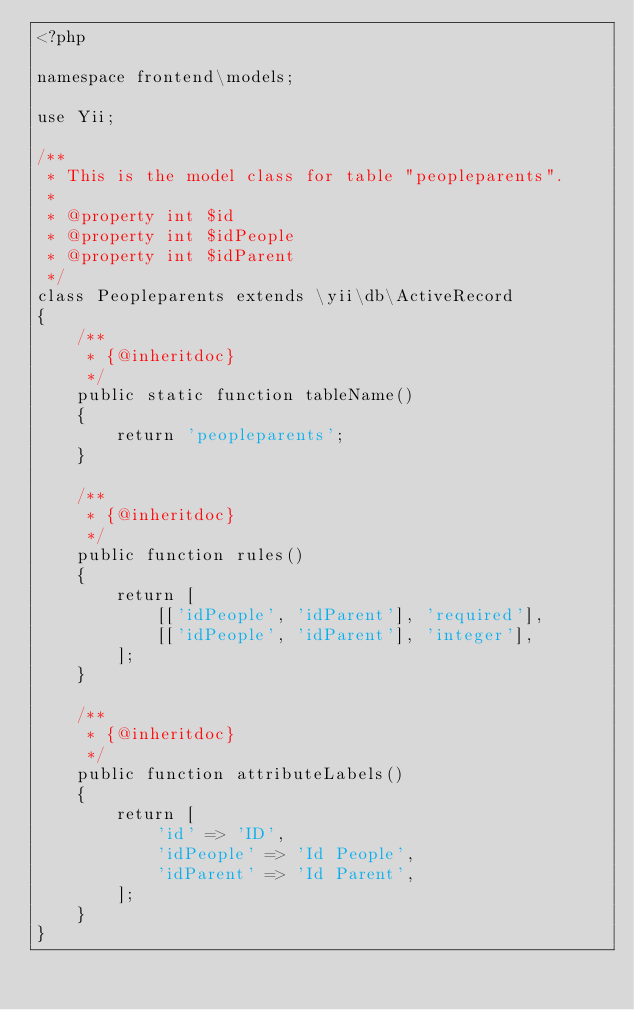Convert code to text. <code><loc_0><loc_0><loc_500><loc_500><_PHP_><?php

namespace frontend\models;

use Yii;

/**
 * This is the model class for table "peopleparents".
 *
 * @property int $id
 * @property int $idPeople
 * @property int $idParent
 */
class Peopleparents extends \yii\db\ActiveRecord
{
    /**
     * {@inheritdoc}
     */
    public static function tableName()
    {
        return 'peopleparents';
    }

    /**
     * {@inheritdoc}
     */
    public function rules()
    {
        return [
            [['idPeople', 'idParent'], 'required'],
            [['idPeople', 'idParent'], 'integer'],
        ];
    }

    /**
     * {@inheritdoc}
     */
    public function attributeLabels()
    {
        return [
            'id' => 'ID',
            'idPeople' => 'Id People',
            'idParent' => 'Id Parent',
        ];
    }
}
</code> 